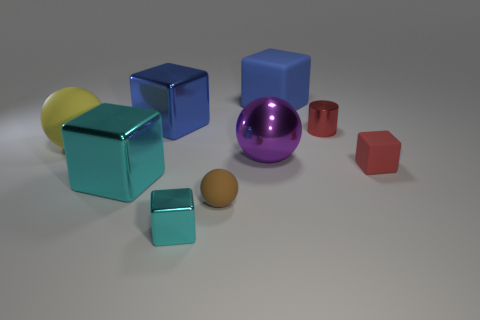What number of tiny objects are either yellow rubber things or cyan metal cubes?
Ensure brevity in your answer.  1. How many tiny things have the same material as the large cyan object?
Keep it short and to the point. 2. What is the size of the shiny block behind the tiny matte cube?
Make the answer very short. Large. There is a big blue matte object that is behind the metallic block behind the small red cylinder; what shape is it?
Provide a short and direct response. Cube. There is a tiny metal object that is right of the blue thing right of the large metallic sphere; how many rubber blocks are on the right side of it?
Your answer should be compact. 1. Are there fewer red cylinders behind the tiny red shiny cylinder than yellow spheres?
Keep it short and to the point. Yes. Is there anything else that is the same shape as the large yellow thing?
Your response must be concise. Yes. The tiny thing that is behind the small red rubber cube has what shape?
Ensure brevity in your answer.  Cylinder. There is a tiny metal object right of the big matte object on the right side of the blue block that is to the left of the blue rubber block; what shape is it?
Offer a terse response. Cylinder. How many objects are small cubes or large rubber things?
Provide a short and direct response. 4. 